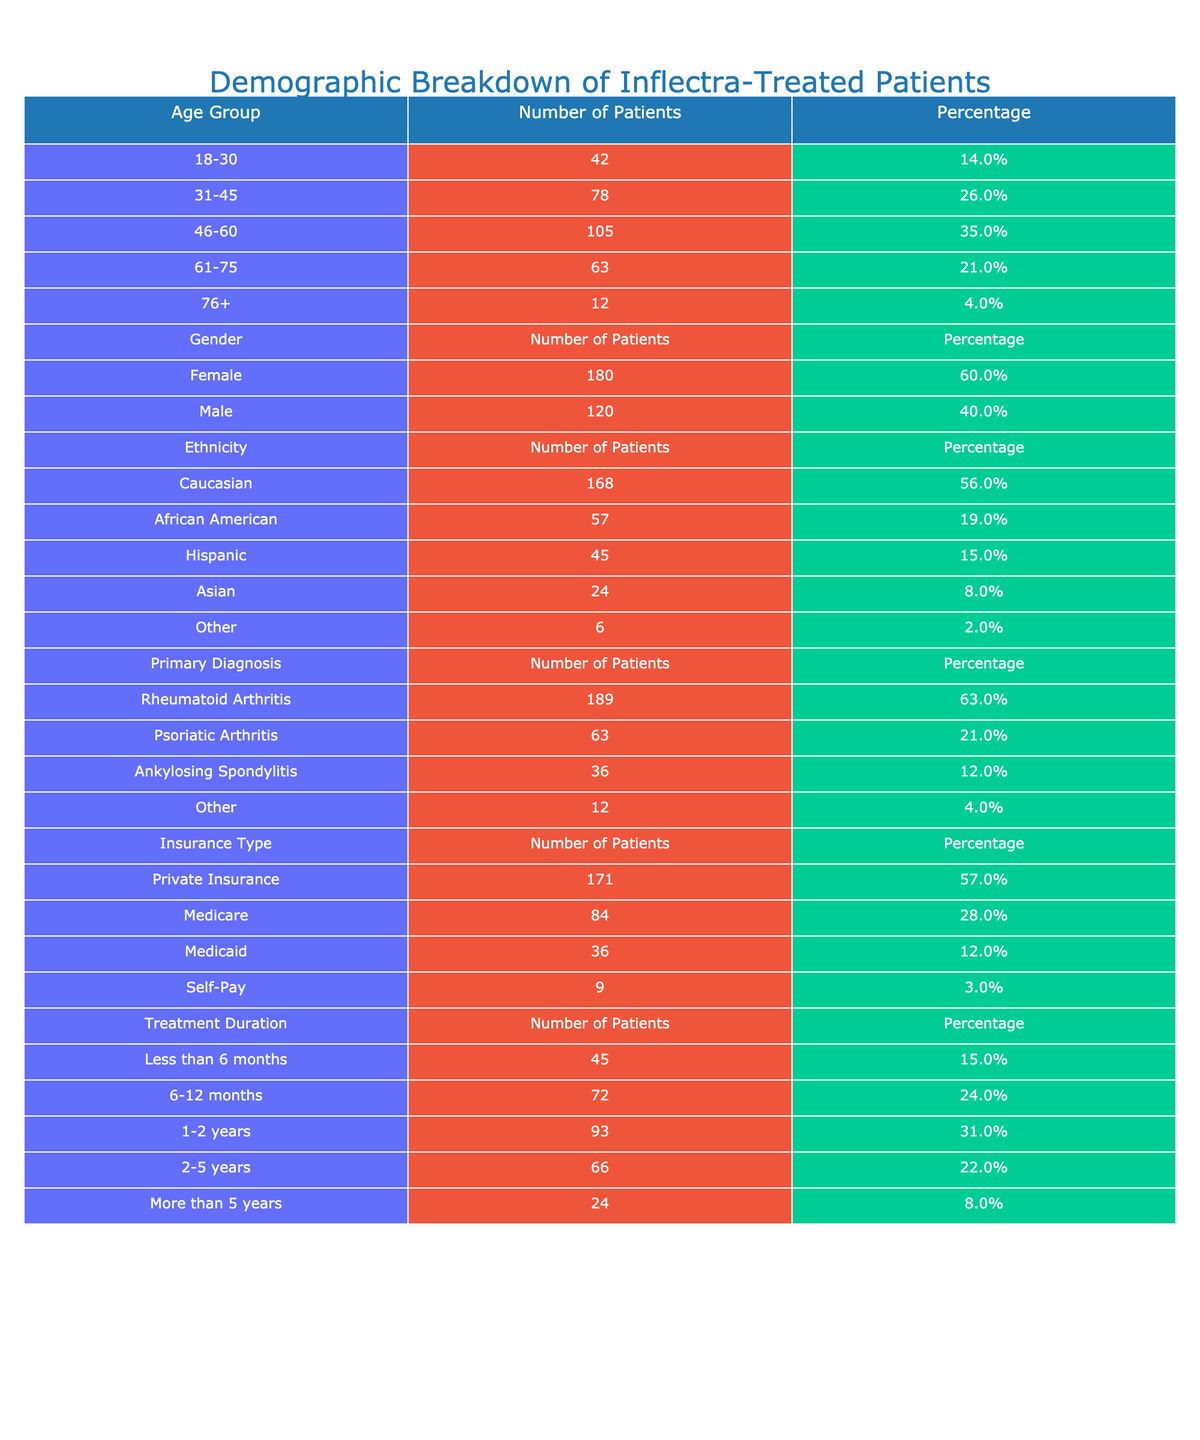What is the percentage of male patients treated with Inflectra? There are 120 male patients and the total number of patients is 300 (180 female + 120 male). The percentage of male patients is calculated as (120 / 300) * 100 = 40%.
Answer: 40% What is the number of patients aged 46-60 treated with Inflectra? Referring directly to the "Age Group" section of the table, the number of patients in the age group 46-60 is given as 105.
Answer: 105 Which primary diagnosis has the highest patient count among Inflectra-treated patients? Looking at the "Primary Diagnosis" section, Rheumatoid Arthritis has the highest count with 189 patients.
Answer: Rheumatoid Arthritis What is the total percentage of patients receiving treatment for less than 1 year? Adding the percentages for 'Less than 6 months' (15%) and '6-12 months' (24%) gives us 15% + 24% = 39%.
Answer: 39% What proportion of patients is covered by Medicaid? From the "Insurance Type" section, there are 36 patients with Medicaid coverage out of 300 total patients, so the proportion is 36/300 = 12%.
Answer: 12% Is the percentage of female patients greater than that of male patients? The percentage of female patients is 60%, while that of male patients is 40%. Since 60% is greater than 40%, the statement is true.
Answer: Yes How many more patients have Rheumatoid Arthritis compared to Ankylosing Spondylitis? To find this, we subtract the number of patients with Ankylosing Spondylitis (36) from those with Rheumatoid Arthritis (189). The result is 189 - 36 = 153 patients.
Answer: 153 What is the average age group of the patients treated with Inflectra? We cannot directly average the age groups numerically, but we can observe that the majority of patients (35%) are in the 46-60 age group, which suggests this group represents the average age demographic.
Answer: 46-60 Among the different ethnicities, which one has the least number of Inflectra-treated patients? By examining the "Ethnicity" section, Other has the least number of patients, accounting for 6 patients.
Answer: Other What is the total number of Inflectra-treated patients with a treatment duration of 1-2 years? The "Treatment Duration" section shows that the number of patients in the 1-2 years category is 93.
Answer: 93 